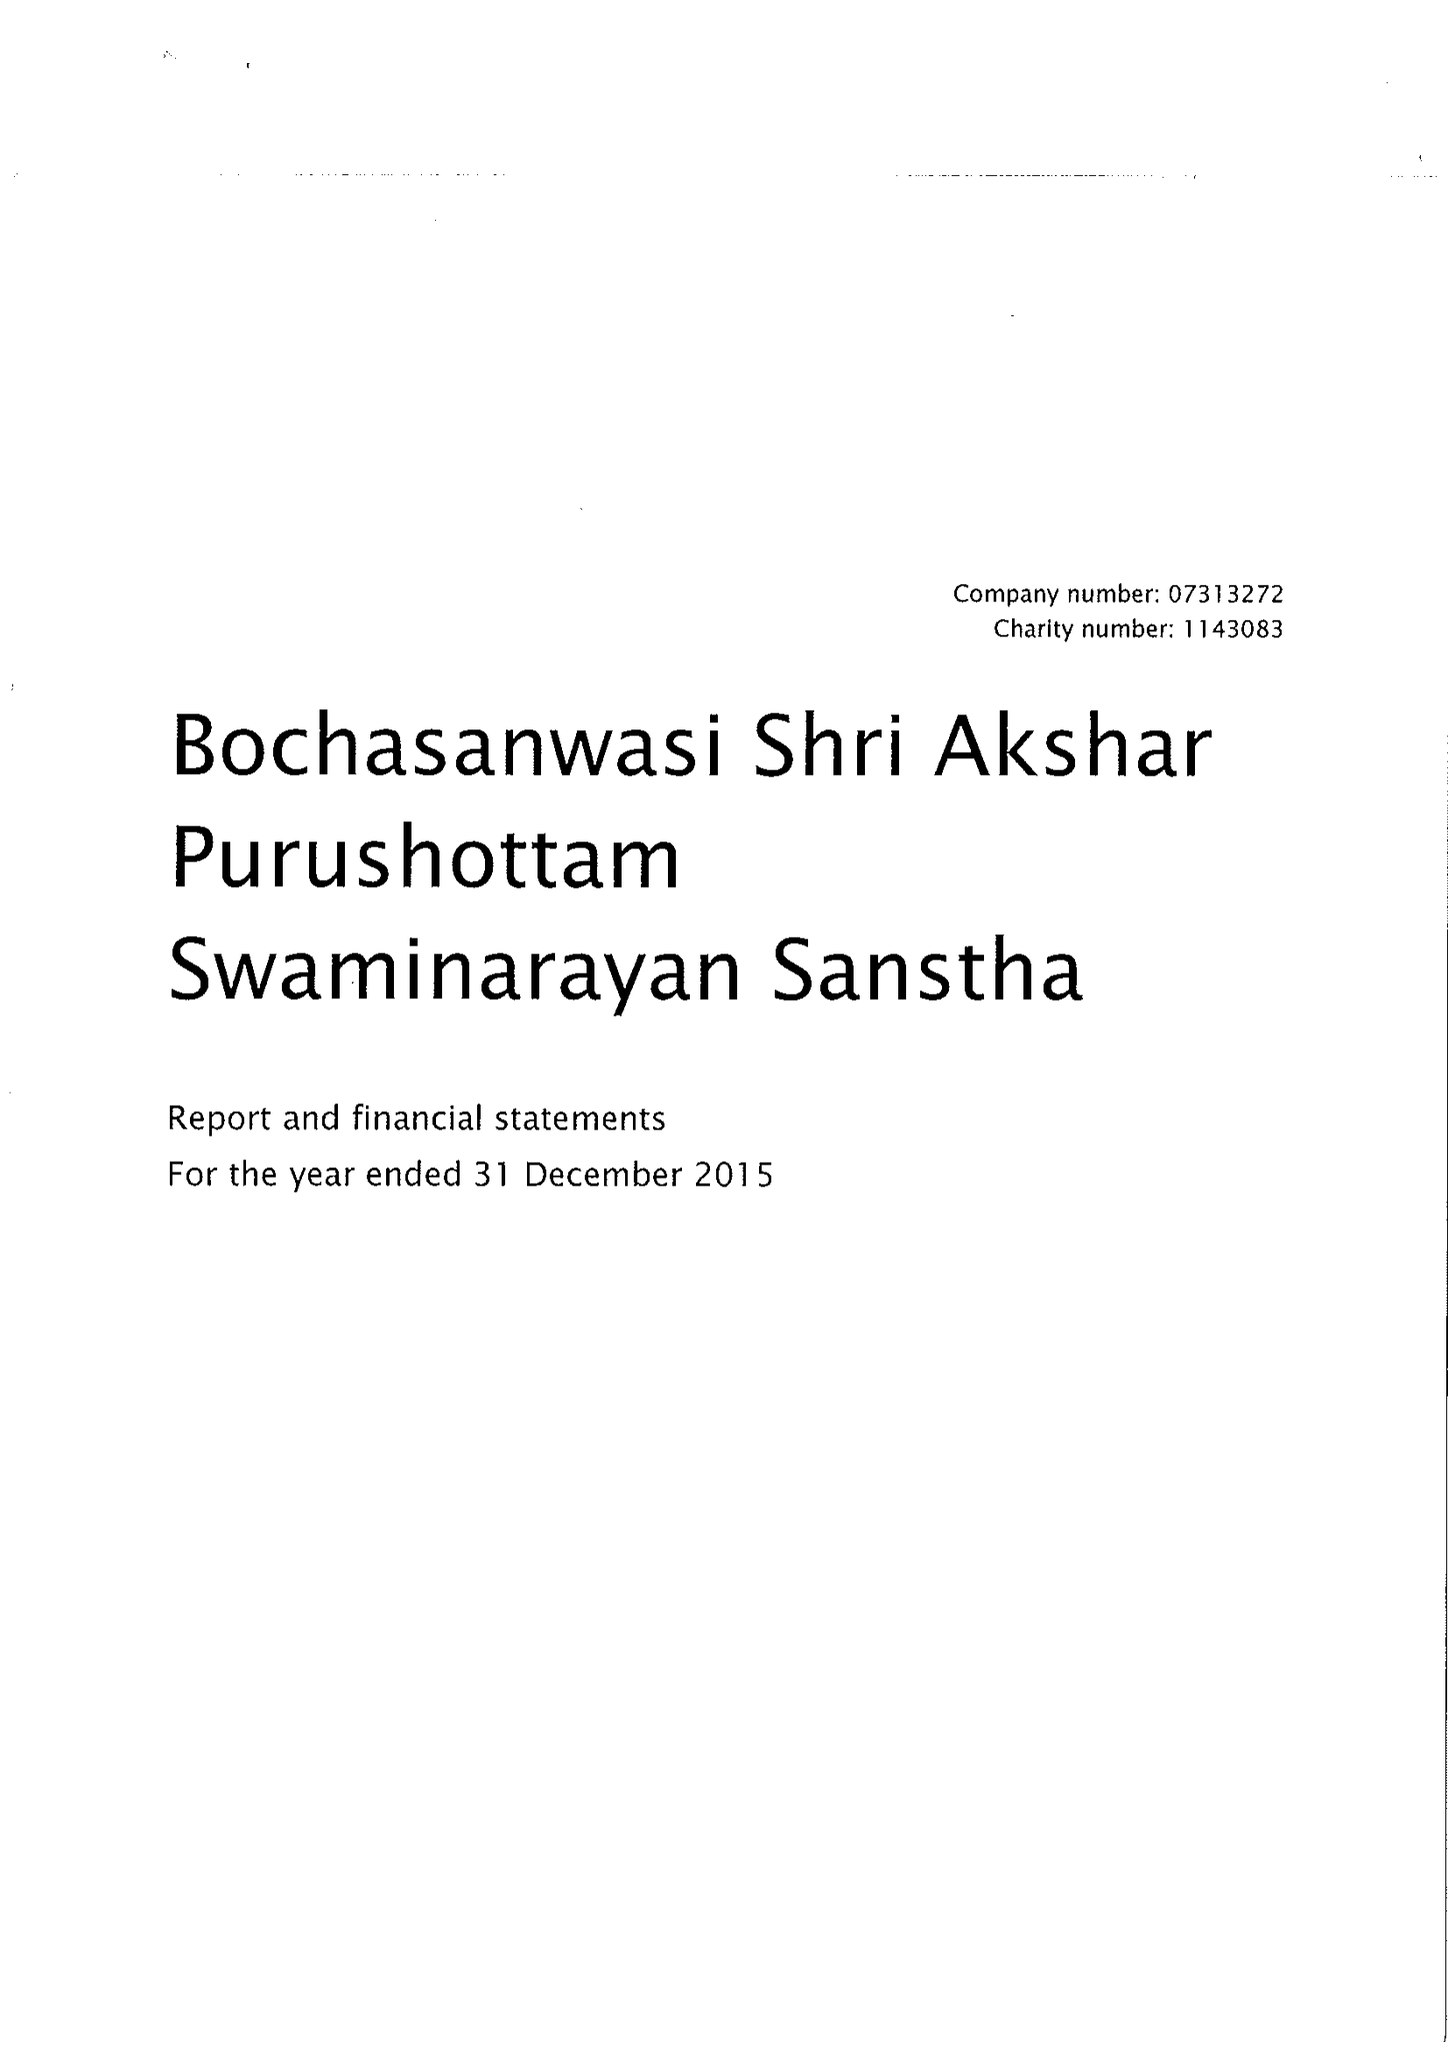What is the value for the address__post_town?
Answer the question using a single word or phrase. LONDON 